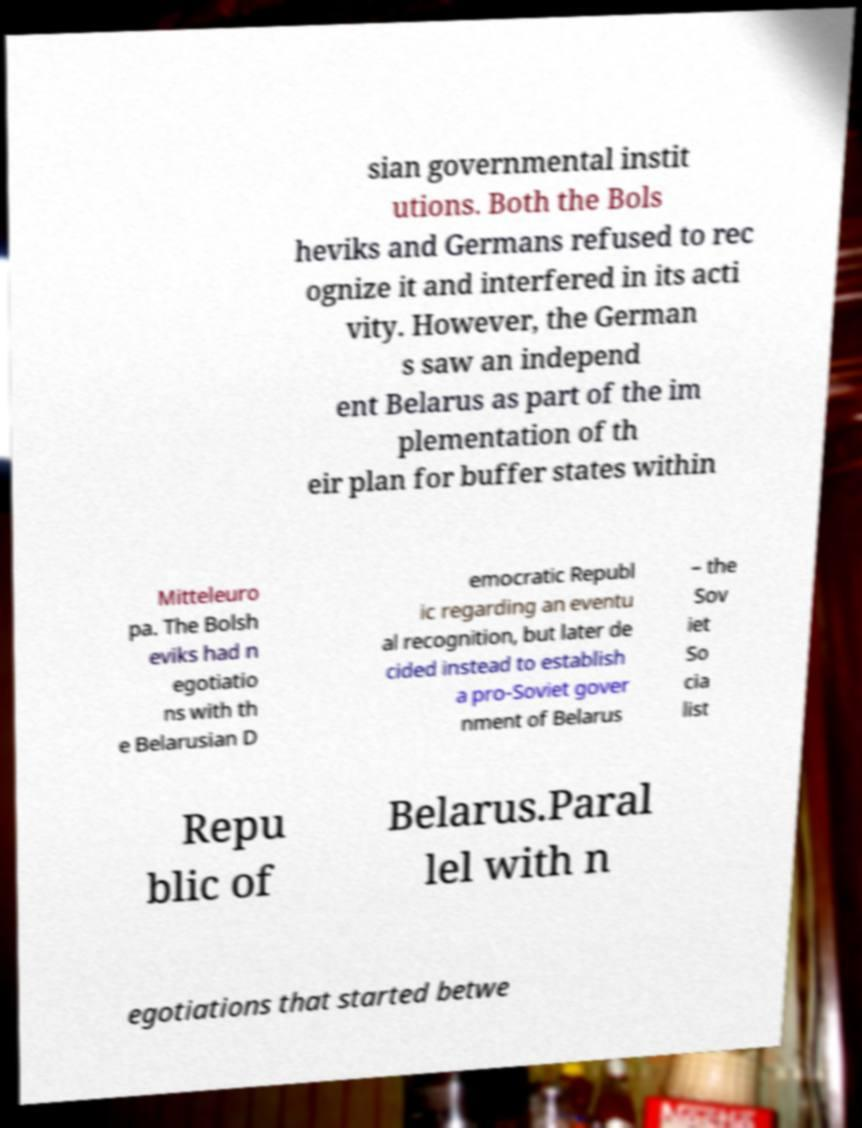What messages or text are displayed in this image? I need them in a readable, typed format. sian governmental instit utions. Both the Bols heviks and Germans refused to rec ognize it and interfered in its acti vity. However, the German s saw an independ ent Belarus as part of the im plementation of th eir plan for buffer states within Mitteleuro pa. The Bolsh eviks had n egotiatio ns with th e Belarusian D emocratic Republ ic regarding an eventu al recognition, but later de cided instead to establish a pro-Soviet gover nment of Belarus – the Sov iet So cia list Repu blic of Belarus.Paral lel with n egotiations that started betwe 